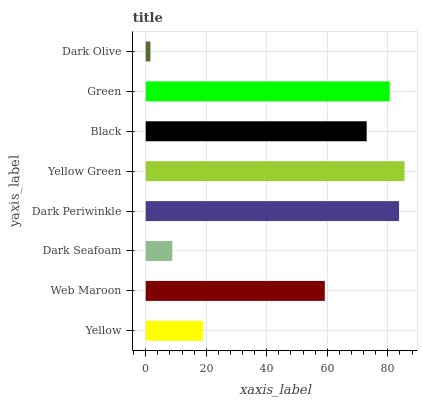Is Dark Olive the minimum?
Answer yes or no. Yes. Is Yellow Green the maximum?
Answer yes or no. Yes. Is Web Maroon the minimum?
Answer yes or no. No. Is Web Maroon the maximum?
Answer yes or no. No. Is Web Maroon greater than Yellow?
Answer yes or no. Yes. Is Yellow less than Web Maroon?
Answer yes or no. Yes. Is Yellow greater than Web Maroon?
Answer yes or no. No. Is Web Maroon less than Yellow?
Answer yes or no. No. Is Black the high median?
Answer yes or no. Yes. Is Web Maroon the low median?
Answer yes or no. Yes. Is Yellow Green the high median?
Answer yes or no. No. Is Green the low median?
Answer yes or no. No. 